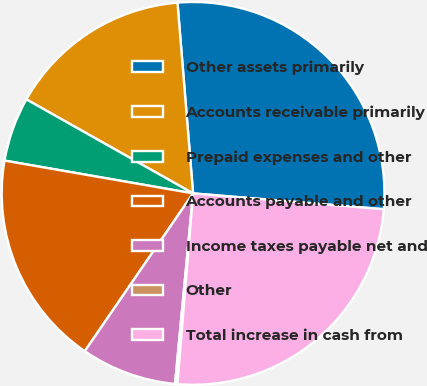Convert chart. <chart><loc_0><loc_0><loc_500><loc_500><pie_chart><fcel>Other assets primarily<fcel>Accounts receivable primarily<fcel>Prepaid expenses and other<fcel>Accounts payable and other<fcel>Income taxes payable net and<fcel>Other<fcel>Total increase in cash from<nl><fcel>27.62%<fcel>15.53%<fcel>5.43%<fcel>18.17%<fcel>8.07%<fcel>0.2%<fcel>24.98%<nl></chart> 